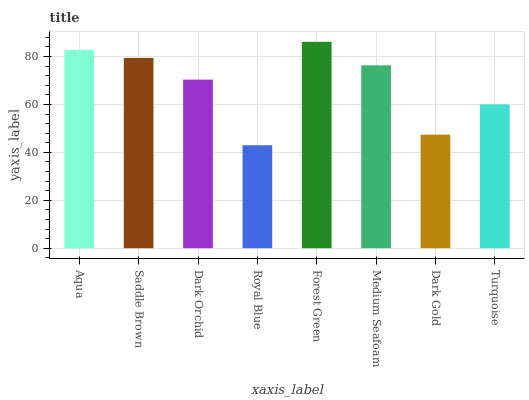Is Royal Blue the minimum?
Answer yes or no. Yes. Is Forest Green the maximum?
Answer yes or no. Yes. Is Saddle Brown the minimum?
Answer yes or no. No. Is Saddle Brown the maximum?
Answer yes or no. No. Is Aqua greater than Saddle Brown?
Answer yes or no. Yes. Is Saddle Brown less than Aqua?
Answer yes or no. Yes. Is Saddle Brown greater than Aqua?
Answer yes or no. No. Is Aqua less than Saddle Brown?
Answer yes or no. No. Is Medium Seafoam the high median?
Answer yes or no. Yes. Is Dark Orchid the low median?
Answer yes or no. Yes. Is Dark Gold the high median?
Answer yes or no. No. Is Aqua the low median?
Answer yes or no. No. 